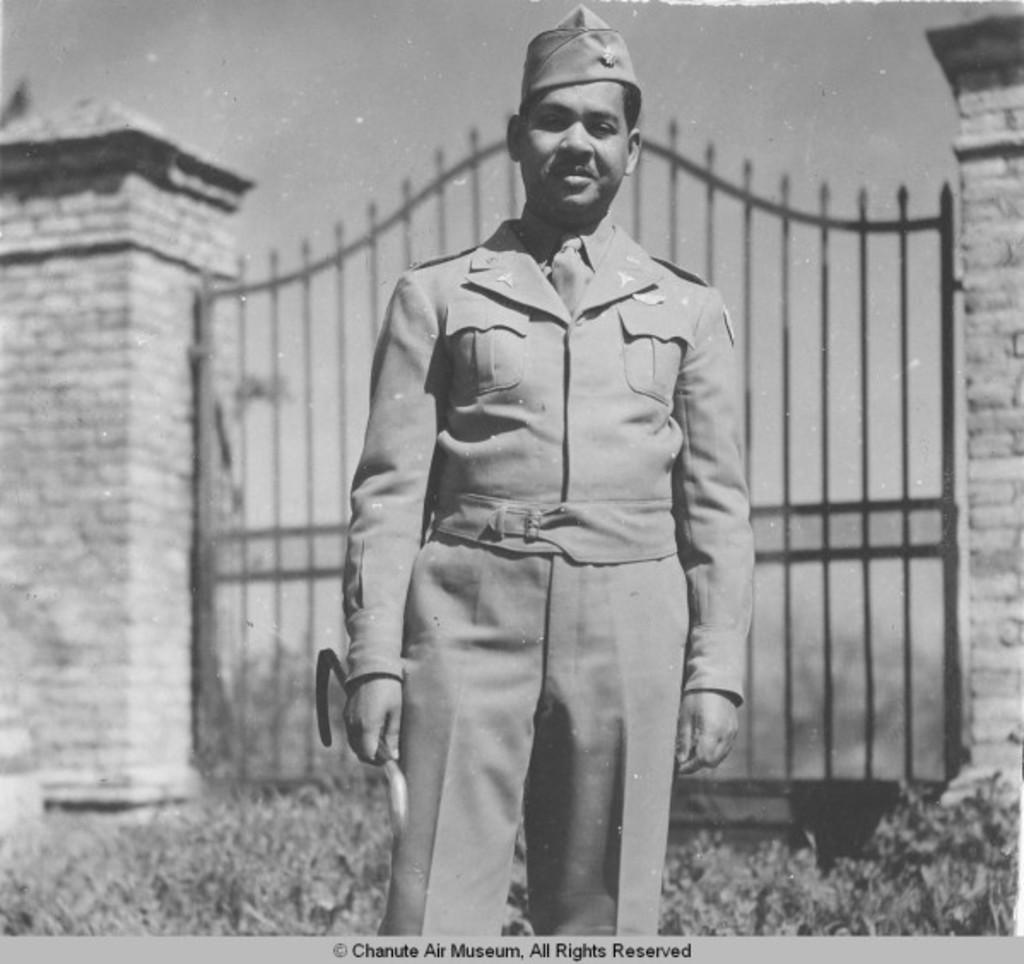What is the main subject of the image? There is a person in the image. What is the person wearing? The person is wearing a uniform. What is the person's posture in the image? The person is standing. What can be seen in the background of the image? There is a gate in the background of the image. How is the gate depicted in the image? The gate is blurred. What type of system is the person using to walk in the image? There is no system present in the image, and the person is simply standing. Can you tell me how many basins are visible in the image? There are no basins present in the image. 